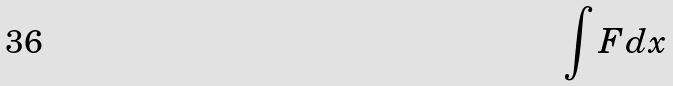<formula> <loc_0><loc_0><loc_500><loc_500>\int F d x</formula> 